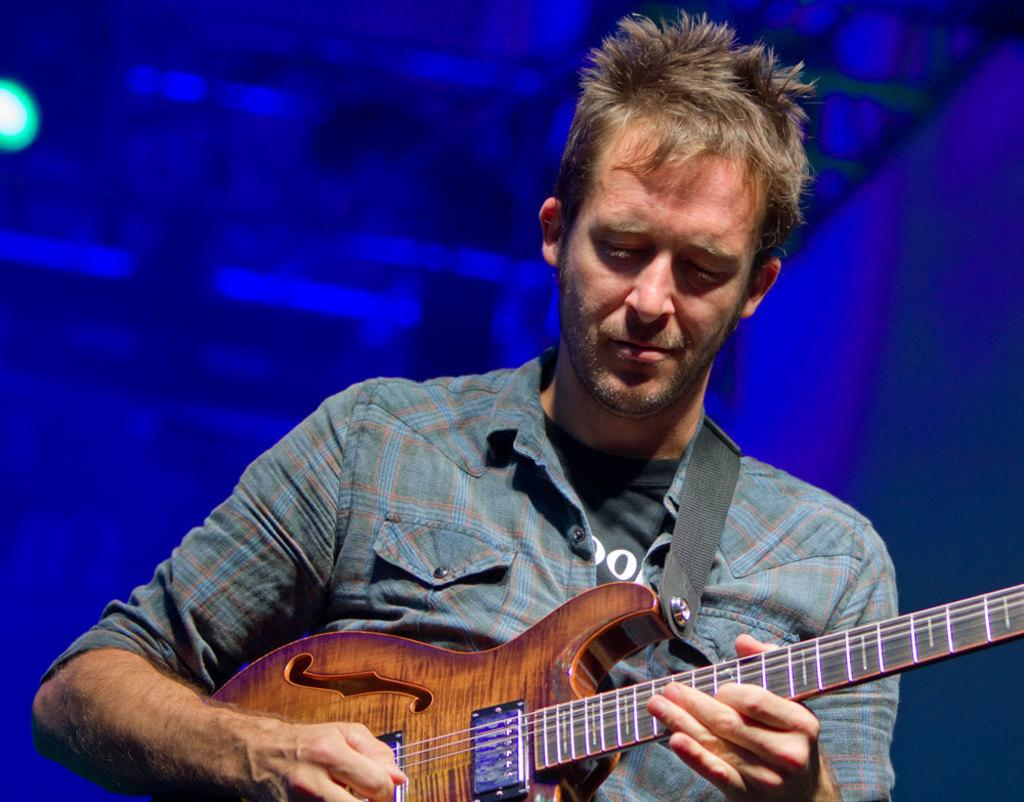What is the main subject of the image? There is a person in the image. What is the person doing in the image? The person is playing a guitar. Can you describe the background of the image? There is a blue light in the background of the image. How many kittens can be seen playing with the person in the image? There are no kittens present in the image. 